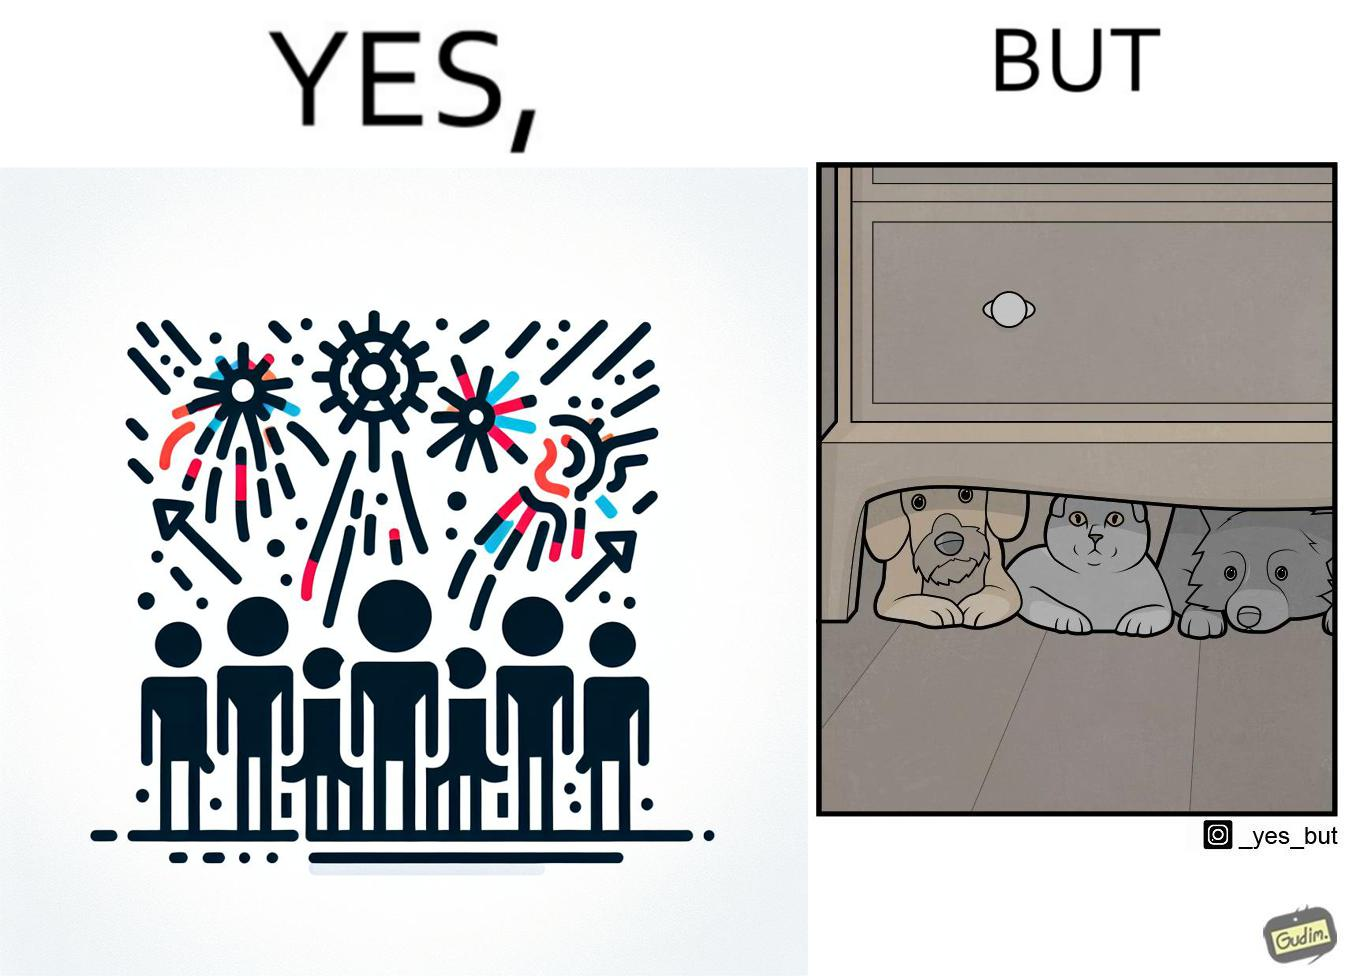Explain the humor or irony in this image. The image is satirical because while firecrackers in the sky look pretty, not everyone likes them. Animals are very scared of the firecrackers. 